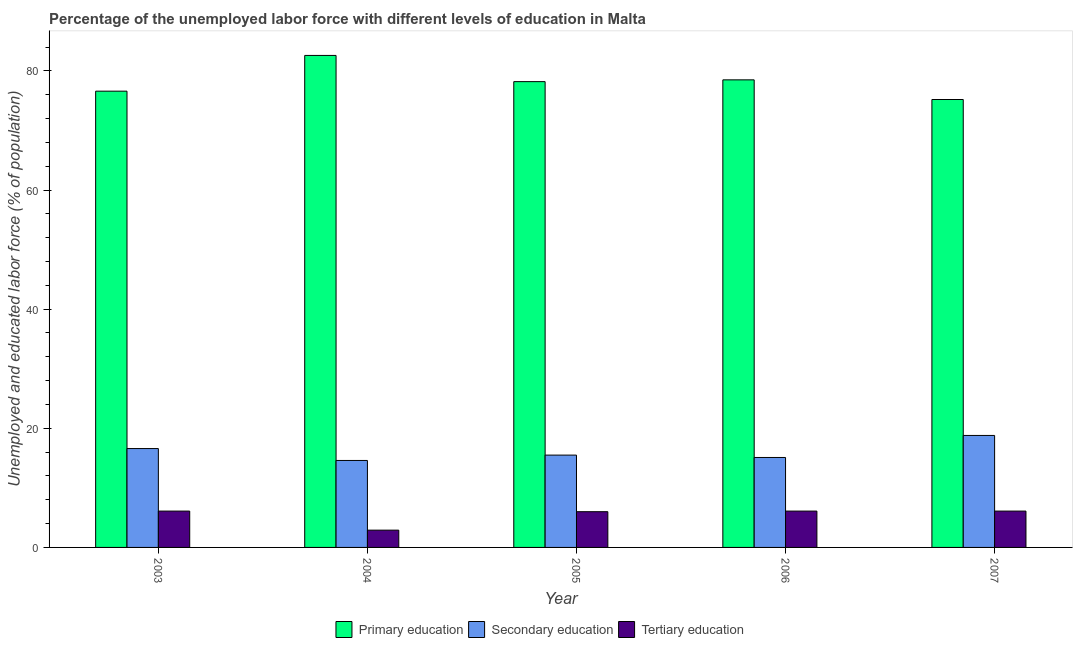How many different coloured bars are there?
Keep it short and to the point. 3. Are the number of bars on each tick of the X-axis equal?
Offer a terse response. Yes. How many bars are there on the 3rd tick from the left?
Ensure brevity in your answer.  3. What is the label of the 3rd group of bars from the left?
Your answer should be very brief. 2005. What is the percentage of labor force who received tertiary education in 2004?
Your answer should be very brief. 2.9. Across all years, what is the maximum percentage of labor force who received tertiary education?
Your response must be concise. 6.1. Across all years, what is the minimum percentage of labor force who received secondary education?
Give a very brief answer. 14.6. In which year was the percentage of labor force who received secondary education maximum?
Keep it short and to the point. 2007. In which year was the percentage of labor force who received primary education minimum?
Make the answer very short. 2007. What is the total percentage of labor force who received primary education in the graph?
Your answer should be compact. 391.1. What is the difference between the percentage of labor force who received tertiary education in 2005 and that in 2006?
Make the answer very short. -0.1. What is the difference between the percentage of labor force who received primary education in 2006 and the percentage of labor force who received secondary education in 2003?
Offer a very short reply. 1.9. What is the average percentage of labor force who received tertiary education per year?
Provide a succinct answer. 5.44. In the year 2006, what is the difference between the percentage of labor force who received secondary education and percentage of labor force who received primary education?
Your answer should be very brief. 0. In how many years, is the percentage of labor force who received tertiary education greater than 80 %?
Offer a terse response. 0. What is the ratio of the percentage of labor force who received tertiary education in 2005 to that in 2006?
Make the answer very short. 0.98. What is the difference between the highest and the second highest percentage of labor force who received primary education?
Give a very brief answer. 4.1. What is the difference between the highest and the lowest percentage of labor force who received tertiary education?
Offer a very short reply. 3.2. In how many years, is the percentage of labor force who received primary education greater than the average percentage of labor force who received primary education taken over all years?
Provide a short and direct response. 2. Is the sum of the percentage of labor force who received primary education in 2004 and 2006 greater than the maximum percentage of labor force who received tertiary education across all years?
Give a very brief answer. Yes. How many bars are there?
Provide a short and direct response. 15. How many years are there in the graph?
Offer a terse response. 5. Does the graph contain grids?
Ensure brevity in your answer.  No. Where does the legend appear in the graph?
Make the answer very short. Bottom center. What is the title of the graph?
Provide a succinct answer. Percentage of the unemployed labor force with different levels of education in Malta. What is the label or title of the X-axis?
Make the answer very short. Year. What is the label or title of the Y-axis?
Offer a very short reply. Unemployed and educated labor force (% of population). What is the Unemployed and educated labor force (% of population) of Primary education in 2003?
Your response must be concise. 76.6. What is the Unemployed and educated labor force (% of population) of Secondary education in 2003?
Keep it short and to the point. 16.6. What is the Unemployed and educated labor force (% of population) in Tertiary education in 2003?
Offer a terse response. 6.1. What is the Unemployed and educated labor force (% of population) in Primary education in 2004?
Your answer should be very brief. 82.6. What is the Unemployed and educated labor force (% of population) of Secondary education in 2004?
Provide a short and direct response. 14.6. What is the Unemployed and educated labor force (% of population) in Tertiary education in 2004?
Your response must be concise. 2.9. What is the Unemployed and educated labor force (% of population) of Primary education in 2005?
Provide a succinct answer. 78.2. What is the Unemployed and educated labor force (% of population) in Secondary education in 2005?
Offer a very short reply. 15.5. What is the Unemployed and educated labor force (% of population) in Tertiary education in 2005?
Offer a very short reply. 6. What is the Unemployed and educated labor force (% of population) of Primary education in 2006?
Keep it short and to the point. 78.5. What is the Unemployed and educated labor force (% of population) in Secondary education in 2006?
Offer a terse response. 15.1. What is the Unemployed and educated labor force (% of population) in Tertiary education in 2006?
Give a very brief answer. 6.1. What is the Unemployed and educated labor force (% of population) in Primary education in 2007?
Ensure brevity in your answer.  75.2. What is the Unemployed and educated labor force (% of population) in Secondary education in 2007?
Your response must be concise. 18.8. What is the Unemployed and educated labor force (% of population) in Tertiary education in 2007?
Your response must be concise. 6.1. Across all years, what is the maximum Unemployed and educated labor force (% of population) in Primary education?
Give a very brief answer. 82.6. Across all years, what is the maximum Unemployed and educated labor force (% of population) in Secondary education?
Your answer should be compact. 18.8. Across all years, what is the maximum Unemployed and educated labor force (% of population) of Tertiary education?
Provide a short and direct response. 6.1. Across all years, what is the minimum Unemployed and educated labor force (% of population) of Primary education?
Your answer should be compact. 75.2. Across all years, what is the minimum Unemployed and educated labor force (% of population) of Secondary education?
Make the answer very short. 14.6. Across all years, what is the minimum Unemployed and educated labor force (% of population) in Tertiary education?
Ensure brevity in your answer.  2.9. What is the total Unemployed and educated labor force (% of population) of Primary education in the graph?
Offer a terse response. 391.1. What is the total Unemployed and educated labor force (% of population) of Secondary education in the graph?
Keep it short and to the point. 80.6. What is the total Unemployed and educated labor force (% of population) in Tertiary education in the graph?
Provide a succinct answer. 27.2. What is the difference between the Unemployed and educated labor force (% of population) in Primary education in 2003 and that in 2004?
Make the answer very short. -6. What is the difference between the Unemployed and educated labor force (% of population) of Secondary education in 2003 and that in 2006?
Keep it short and to the point. 1.5. What is the difference between the Unemployed and educated labor force (% of population) of Tertiary education in 2003 and that in 2006?
Offer a terse response. 0. What is the difference between the Unemployed and educated labor force (% of population) of Primary education in 2003 and that in 2007?
Give a very brief answer. 1.4. What is the difference between the Unemployed and educated labor force (% of population) of Secondary education in 2003 and that in 2007?
Your answer should be compact. -2.2. What is the difference between the Unemployed and educated labor force (% of population) in Primary education in 2004 and that in 2005?
Provide a short and direct response. 4.4. What is the difference between the Unemployed and educated labor force (% of population) of Tertiary education in 2004 and that in 2005?
Your answer should be very brief. -3.1. What is the difference between the Unemployed and educated labor force (% of population) of Primary education in 2004 and that in 2007?
Offer a very short reply. 7.4. What is the difference between the Unemployed and educated labor force (% of population) of Tertiary education in 2004 and that in 2007?
Ensure brevity in your answer.  -3.2. What is the difference between the Unemployed and educated labor force (% of population) of Primary education in 2005 and that in 2006?
Give a very brief answer. -0.3. What is the difference between the Unemployed and educated labor force (% of population) of Secondary education in 2005 and that in 2007?
Make the answer very short. -3.3. What is the difference between the Unemployed and educated labor force (% of population) of Primary education in 2006 and that in 2007?
Ensure brevity in your answer.  3.3. What is the difference between the Unemployed and educated labor force (% of population) in Secondary education in 2006 and that in 2007?
Offer a terse response. -3.7. What is the difference between the Unemployed and educated labor force (% of population) of Tertiary education in 2006 and that in 2007?
Provide a short and direct response. 0. What is the difference between the Unemployed and educated labor force (% of population) of Primary education in 2003 and the Unemployed and educated labor force (% of population) of Tertiary education in 2004?
Make the answer very short. 73.7. What is the difference between the Unemployed and educated labor force (% of population) of Primary education in 2003 and the Unemployed and educated labor force (% of population) of Secondary education in 2005?
Offer a terse response. 61.1. What is the difference between the Unemployed and educated labor force (% of population) in Primary education in 2003 and the Unemployed and educated labor force (% of population) in Tertiary education in 2005?
Give a very brief answer. 70.6. What is the difference between the Unemployed and educated labor force (% of population) of Secondary education in 2003 and the Unemployed and educated labor force (% of population) of Tertiary education in 2005?
Your response must be concise. 10.6. What is the difference between the Unemployed and educated labor force (% of population) of Primary education in 2003 and the Unemployed and educated labor force (% of population) of Secondary education in 2006?
Ensure brevity in your answer.  61.5. What is the difference between the Unemployed and educated labor force (% of population) in Primary education in 2003 and the Unemployed and educated labor force (% of population) in Tertiary education in 2006?
Give a very brief answer. 70.5. What is the difference between the Unemployed and educated labor force (% of population) in Secondary education in 2003 and the Unemployed and educated labor force (% of population) in Tertiary education in 2006?
Your answer should be very brief. 10.5. What is the difference between the Unemployed and educated labor force (% of population) of Primary education in 2003 and the Unemployed and educated labor force (% of population) of Secondary education in 2007?
Provide a succinct answer. 57.8. What is the difference between the Unemployed and educated labor force (% of population) of Primary education in 2003 and the Unemployed and educated labor force (% of population) of Tertiary education in 2007?
Offer a terse response. 70.5. What is the difference between the Unemployed and educated labor force (% of population) in Secondary education in 2003 and the Unemployed and educated labor force (% of population) in Tertiary education in 2007?
Offer a very short reply. 10.5. What is the difference between the Unemployed and educated labor force (% of population) of Primary education in 2004 and the Unemployed and educated labor force (% of population) of Secondary education in 2005?
Provide a succinct answer. 67.1. What is the difference between the Unemployed and educated labor force (% of population) in Primary education in 2004 and the Unemployed and educated labor force (% of population) in Tertiary education in 2005?
Your answer should be compact. 76.6. What is the difference between the Unemployed and educated labor force (% of population) of Secondary education in 2004 and the Unemployed and educated labor force (% of population) of Tertiary education in 2005?
Provide a succinct answer. 8.6. What is the difference between the Unemployed and educated labor force (% of population) in Primary education in 2004 and the Unemployed and educated labor force (% of population) in Secondary education in 2006?
Provide a short and direct response. 67.5. What is the difference between the Unemployed and educated labor force (% of population) in Primary education in 2004 and the Unemployed and educated labor force (% of population) in Tertiary education in 2006?
Provide a short and direct response. 76.5. What is the difference between the Unemployed and educated labor force (% of population) in Secondary education in 2004 and the Unemployed and educated labor force (% of population) in Tertiary education in 2006?
Your answer should be very brief. 8.5. What is the difference between the Unemployed and educated labor force (% of population) of Primary education in 2004 and the Unemployed and educated labor force (% of population) of Secondary education in 2007?
Your response must be concise. 63.8. What is the difference between the Unemployed and educated labor force (% of population) in Primary education in 2004 and the Unemployed and educated labor force (% of population) in Tertiary education in 2007?
Provide a short and direct response. 76.5. What is the difference between the Unemployed and educated labor force (% of population) in Secondary education in 2004 and the Unemployed and educated labor force (% of population) in Tertiary education in 2007?
Your answer should be compact. 8.5. What is the difference between the Unemployed and educated labor force (% of population) in Primary education in 2005 and the Unemployed and educated labor force (% of population) in Secondary education in 2006?
Offer a terse response. 63.1. What is the difference between the Unemployed and educated labor force (% of population) in Primary education in 2005 and the Unemployed and educated labor force (% of population) in Tertiary education in 2006?
Your answer should be compact. 72.1. What is the difference between the Unemployed and educated labor force (% of population) in Primary education in 2005 and the Unemployed and educated labor force (% of population) in Secondary education in 2007?
Provide a short and direct response. 59.4. What is the difference between the Unemployed and educated labor force (% of population) in Primary education in 2005 and the Unemployed and educated labor force (% of population) in Tertiary education in 2007?
Your answer should be very brief. 72.1. What is the difference between the Unemployed and educated labor force (% of population) of Secondary education in 2005 and the Unemployed and educated labor force (% of population) of Tertiary education in 2007?
Keep it short and to the point. 9.4. What is the difference between the Unemployed and educated labor force (% of population) of Primary education in 2006 and the Unemployed and educated labor force (% of population) of Secondary education in 2007?
Give a very brief answer. 59.7. What is the difference between the Unemployed and educated labor force (% of population) of Primary education in 2006 and the Unemployed and educated labor force (% of population) of Tertiary education in 2007?
Offer a very short reply. 72.4. What is the difference between the Unemployed and educated labor force (% of population) in Secondary education in 2006 and the Unemployed and educated labor force (% of population) in Tertiary education in 2007?
Your response must be concise. 9. What is the average Unemployed and educated labor force (% of population) of Primary education per year?
Offer a very short reply. 78.22. What is the average Unemployed and educated labor force (% of population) of Secondary education per year?
Offer a terse response. 16.12. What is the average Unemployed and educated labor force (% of population) of Tertiary education per year?
Provide a succinct answer. 5.44. In the year 2003, what is the difference between the Unemployed and educated labor force (% of population) in Primary education and Unemployed and educated labor force (% of population) in Secondary education?
Provide a succinct answer. 60. In the year 2003, what is the difference between the Unemployed and educated labor force (% of population) of Primary education and Unemployed and educated labor force (% of population) of Tertiary education?
Your answer should be compact. 70.5. In the year 2004, what is the difference between the Unemployed and educated labor force (% of population) in Primary education and Unemployed and educated labor force (% of population) in Tertiary education?
Offer a very short reply. 79.7. In the year 2004, what is the difference between the Unemployed and educated labor force (% of population) of Secondary education and Unemployed and educated labor force (% of population) of Tertiary education?
Your response must be concise. 11.7. In the year 2005, what is the difference between the Unemployed and educated labor force (% of population) in Primary education and Unemployed and educated labor force (% of population) in Secondary education?
Keep it short and to the point. 62.7. In the year 2005, what is the difference between the Unemployed and educated labor force (% of population) of Primary education and Unemployed and educated labor force (% of population) of Tertiary education?
Offer a terse response. 72.2. In the year 2005, what is the difference between the Unemployed and educated labor force (% of population) in Secondary education and Unemployed and educated labor force (% of population) in Tertiary education?
Your answer should be very brief. 9.5. In the year 2006, what is the difference between the Unemployed and educated labor force (% of population) of Primary education and Unemployed and educated labor force (% of population) of Secondary education?
Provide a short and direct response. 63.4. In the year 2006, what is the difference between the Unemployed and educated labor force (% of population) of Primary education and Unemployed and educated labor force (% of population) of Tertiary education?
Your answer should be very brief. 72.4. In the year 2006, what is the difference between the Unemployed and educated labor force (% of population) in Secondary education and Unemployed and educated labor force (% of population) in Tertiary education?
Make the answer very short. 9. In the year 2007, what is the difference between the Unemployed and educated labor force (% of population) of Primary education and Unemployed and educated labor force (% of population) of Secondary education?
Provide a succinct answer. 56.4. In the year 2007, what is the difference between the Unemployed and educated labor force (% of population) in Primary education and Unemployed and educated labor force (% of population) in Tertiary education?
Offer a very short reply. 69.1. In the year 2007, what is the difference between the Unemployed and educated labor force (% of population) in Secondary education and Unemployed and educated labor force (% of population) in Tertiary education?
Your response must be concise. 12.7. What is the ratio of the Unemployed and educated labor force (% of population) in Primary education in 2003 to that in 2004?
Offer a terse response. 0.93. What is the ratio of the Unemployed and educated labor force (% of population) in Secondary education in 2003 to that in 2004?
Your answer should be very brief. 1.14. What is the ratio of the Unemployed and educated labor force (% of population) in Tertiary education in 2003 to that in 2004?
Ensure brevity in your answer.  2.1. What is the ratio of the Unemployed and educated labor force (% of population) in Primary education in 2003 to that in 2005?
Your answer should be very brief. 0.98. What is the ratio of the Unemployed and educated labor force (% of population) of Secondary education in 2003 to that in 2005?
Make the answer very short. 1.07. What is the ratio of the Unemployed and educated labor force (% of population) of Tertiary education in 2003 to that in 2005?
Your response must be concise. 1.02. What is the ratio of the Unemployed and educated labor force (% of population) of Primary education in 2003 to that in 2006?
Provide a succinct answer. 0.98. What is the ratio of the Unemployed and educated labor force (% of population) of Secondary education in 2003 to that in 2006?
Ensure brevity in your answer.  1.1. What is the ratio of the Unemployed and educated labor force (% of population) of Tertiary education in 2003 to that in 2006?
Your answer should be very brief. 1. What is the ratio of the Unemployed and educated labor force (% of population) of Primary education in 2003 to that in 2007?
Offer a very short reply. 1.02. What is the ratio of the Unemployed and educated labor force (% of population) of Secondary education in 2003 to that in 2007?
Make the answer very short. 0.88. What is the ratio of the Unemployed and educated labor force (% of population) of Primary education in 2004 to that in 2005?
Provide a succinct answer. 1.06. What is the ratio of the Unemployed and educated labor force (% of population) in Secondary education in 2004 to that in 2005?
Your answer should be very brief. 0.94. What is the ratio of the Unemployed and educated labor force (% of population) in Tertiary education in 2004 to that in 2005?
Give a very brief answer. 0.48. What is the ratio of the Unemployed and educated labor force (% of population) in Primary education in 2004 to that in 2006?
Provide a succinct answer. 1.05. What is the ratio of the Unemployed and educated labor force (% of population) in Secondary education in 2004 to that in 2006?
Offer a very short reply. 0.97. What is the ratio of the Unemployed and educated labor force (% of population) of Tertiary education in 2004 to that in 2006?
Give a very brief answer. 0.48. What is the ratio of the Unemployed and educated labor force (% of population) of Primary education in 2004 to that in 2007?
Give a very brief answer. 1.1. What is the ratio of the Unemployed and educated labor force (% of population) of Secondary education in 2004 to that in 2007?
Provide a short and direct response. 0.78. What is the ratio of the Unemployed and educated labor force (% of population) of Tertiary education in 2004 to that in 2007?
Keep it short and to the point. 0.48. What is the ratio of the Unemployed and educated labor force (% of population) in Secondary education in 2005 to that in 2006?
Your answer should be very brief. 1.03. What is the ratio of the Unemployed and educated labor force (% of population) in Tertiary education in 2005 to that in 2006?
Make the answer very short. 0.98. What is the ratio of the Unemployed and educated labor force (% of population) in Primary education in 2005 to that in 2007?
Offer a very short reply. 1.04. What is the ratio of the Unemployed and educated labor force (% of population) of Secondary education in 2005 to that in 2007?
Provide a short and direct response. 0.82. What is the ratio of the Unemployed and educated labor force (% of population) of Tertiary education in 2005 to that in 2007?
Make the answer very short. 0.98. What is the ratio of the Unemployed and educated labor force (% of population) of Primary education in 2006 to that in 2007?
Your answer should be compact. 1.04. What is the ratio of the Unemployed and educated labor force (% of population) of Secondary education in 2006 to that in 2007?
Offer a very short reply. 0.8. What is the ratio of the Unemployed and educated labor force (% of population) of Tertiary education in 2006 to that in 2007?
Offer a very short reply. 1. What is the difference between the highest and the second highest Unemployed and educated labor force (% of population) in Secondary education?
Your answer should be very brief. 2.2. What is the difference between the highest and the second highest Unemployed and educated labor force (% of population) of Tertiary education?
Offer a terse response. 0. What is the difference between the highest and the lowest Unemployed and educated labor force (% of population) in Secondary education?
Your answer should be compact. 4.2. What is the difference between the highest and the lowest Unemployed and educated labor force (% of population) in Tertiary education?
Your response must be concise. 3.2. 